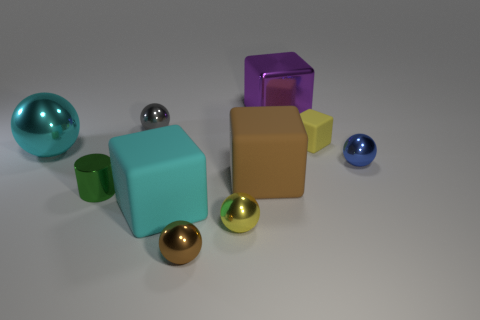Is the number of tiny metallic things in front of the large purple metal object less than the number of yellow rubber objects that are on the left side of the tiny yellow cube?
Ensure brevity in your answer.  No. There is a brown object in front of the cube left of the big matte cube on the right side of the small brown metal ball; what is it made of?
Make the answer very short. Metal. There is a sphere that is on the right side of the small green metallic cylinder and on the left side of the brown sphere; what is its size?
Your answer should be very brief. Small. What number of blocks are tiny brown objects or yellow things?
Offer a very short reply. 1. The metal block that is the same size as the cyan metal thing is what color?
Your answer should be compact. Purple. Is there anything else that is the same shape as the small matte object?
Offer a very short reply. Yes. The other big object that is the same shape as the gray object is what color?
Offer a very short reply. Cyan. How many things are either small metallic things or metal objects in front of the big brown thing?
Offer a very short reply. 5. Is the number of big purple metal blocks right of the large purple shiny object less than the number of tiny yellow shiny things?
Your answer should be compact. Yes. There is a metallic ball on the right side of the yellow object behind the tiny blue shiny ball behind the brown matte block; what is its size?
Provide a succinct answer. Small. 